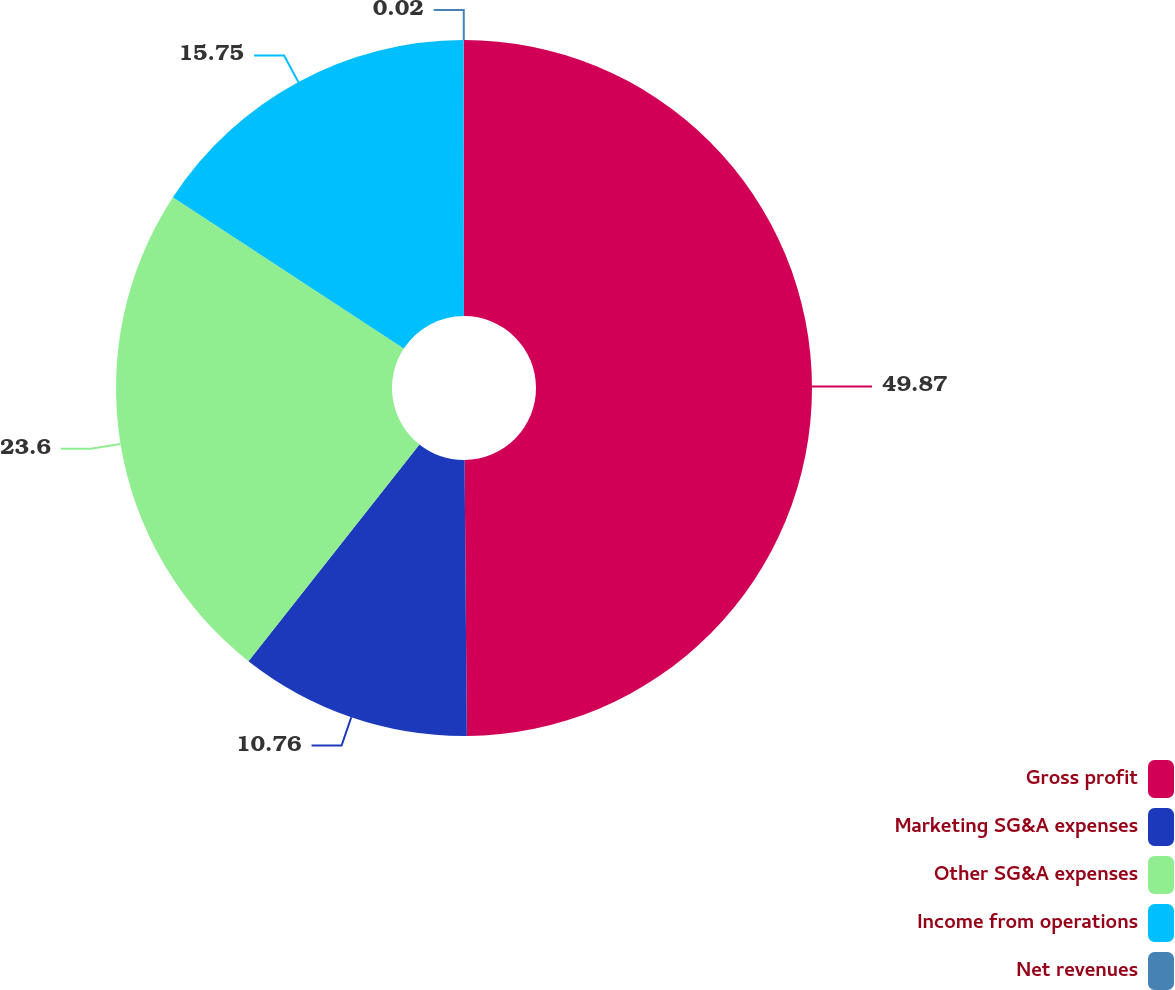Convert chart to OTSL. <chart><loc_0><loc_0><loc_500><loc_500><pie_chart><fcel>Gross profit<fcel>Marketing SG&A expenses<fcel>Other SG&A expenses<fcel>Income from operations<fcel>Net revenues<nl><fcel>49.87%<fcel>10.76%<fcel>23.6%<fcel>15.75%<fcel>0.02%<nl></chart> 